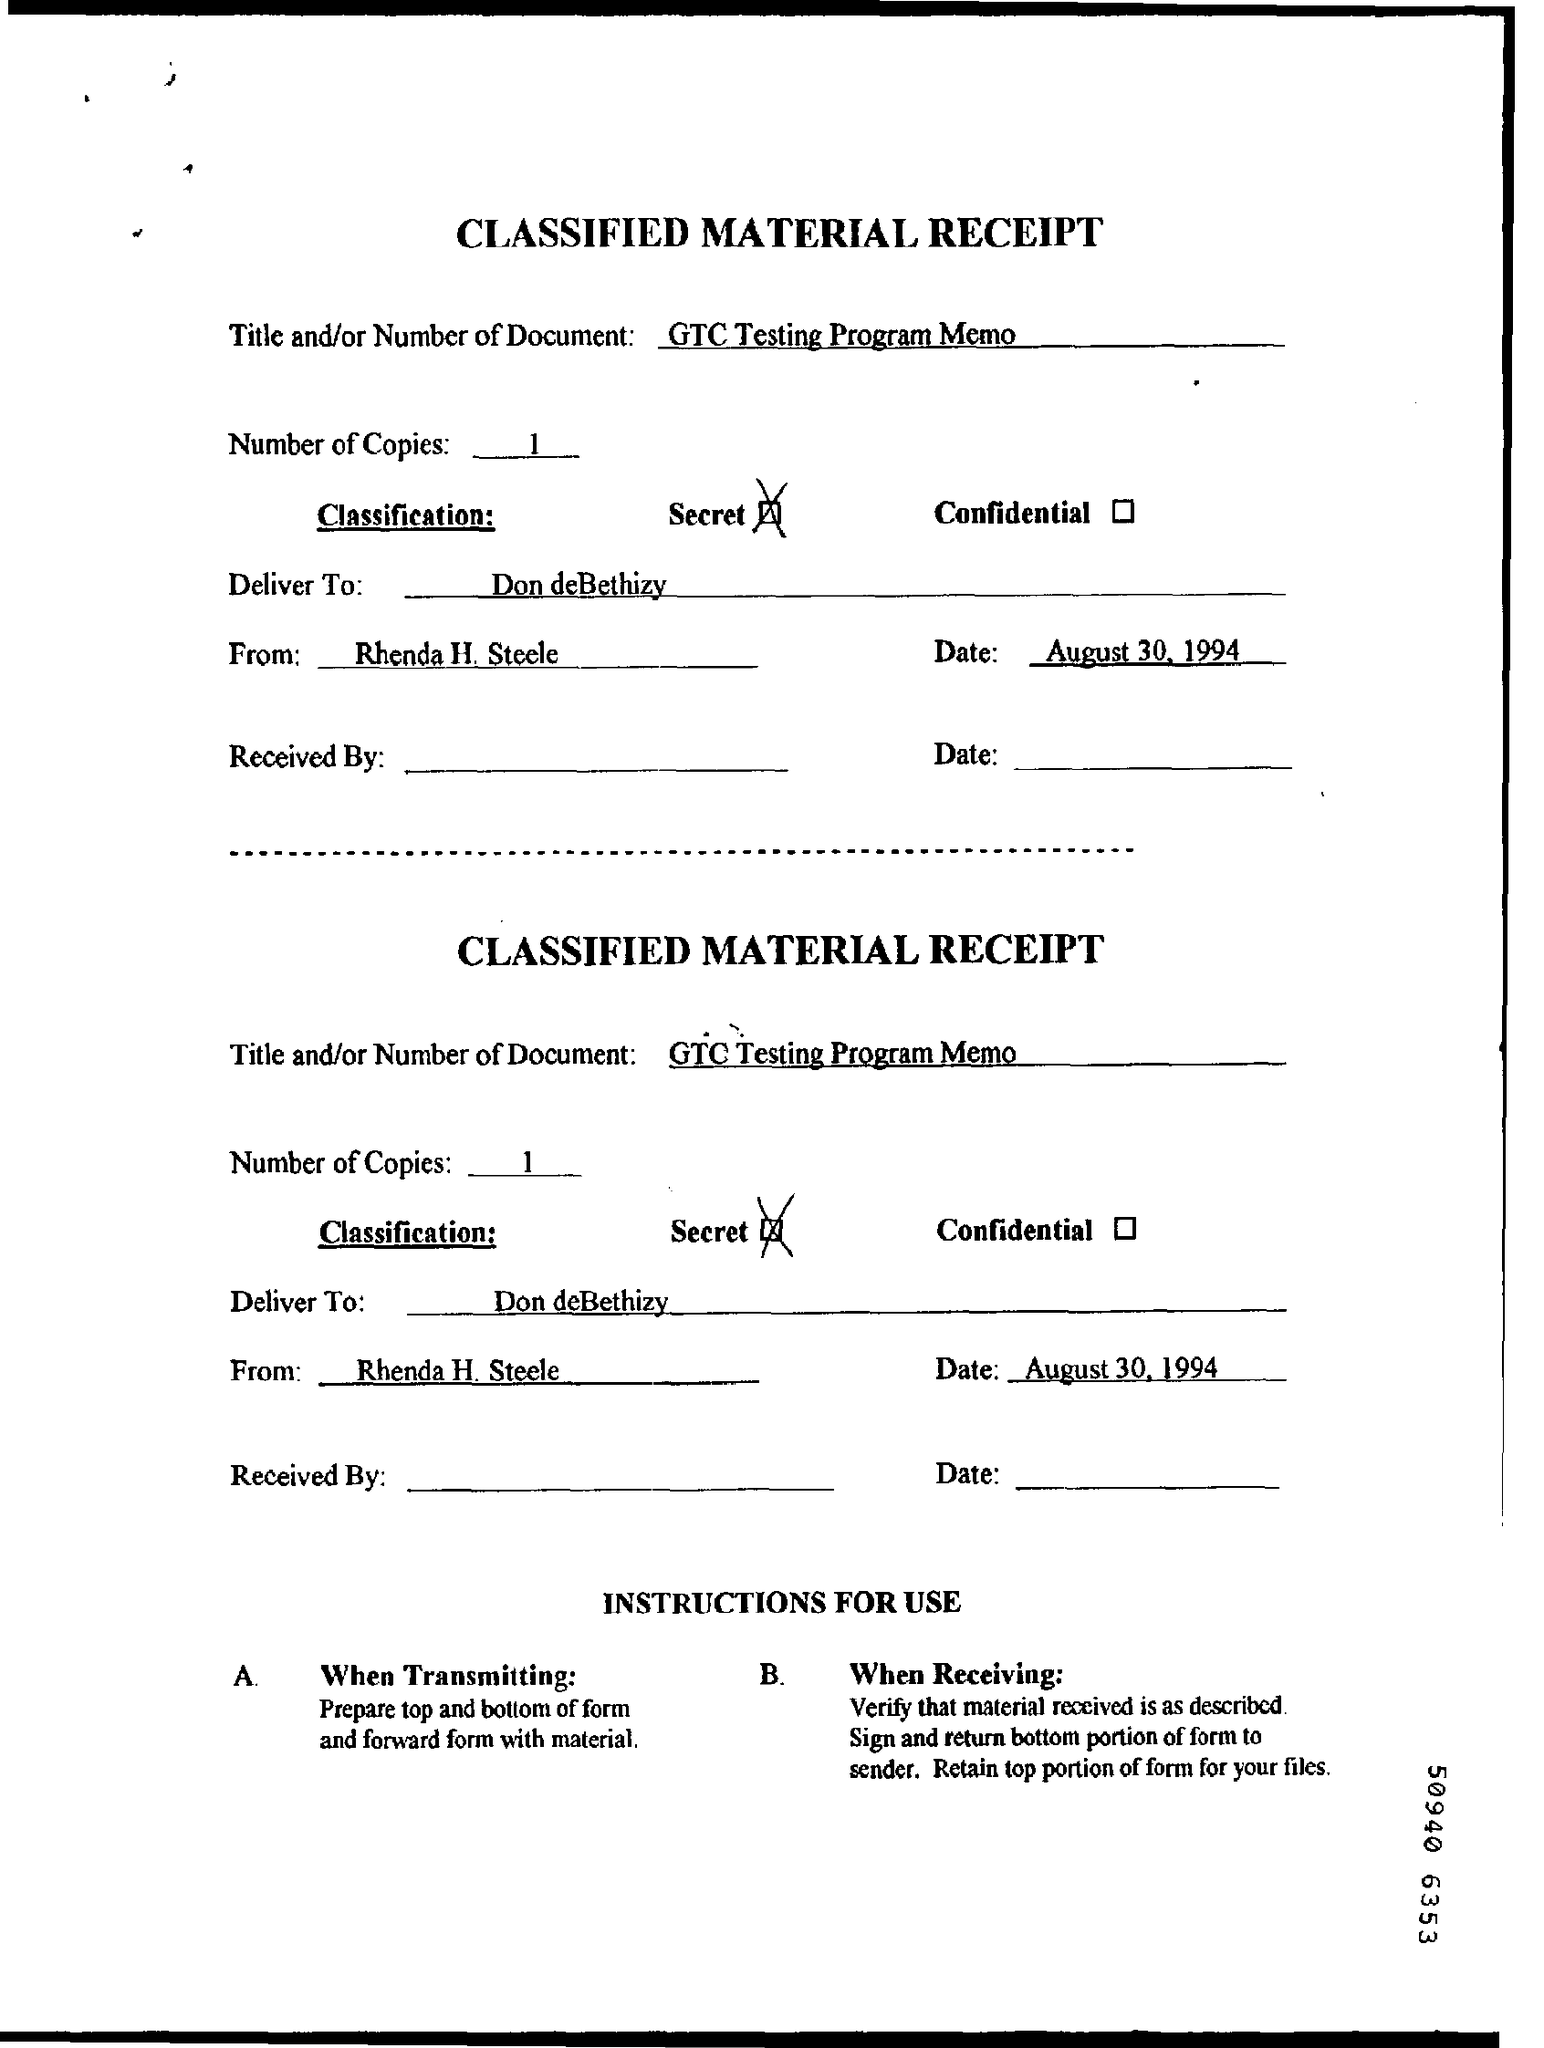What is date of the document?
Offer a very short reply. August 30, 1994. What is no. of copies?
Your answer should be compact. 1. 